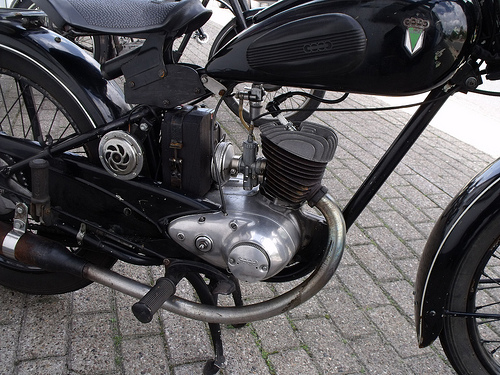<image>
Is the seat on the motorcycle? Yes. Looking at the image, I can see the seat is positioned on top of the motorcycle, with the motorcycle providing support. Is there a bike in front of the road? No. The bike is not in front of the road. The spatial positioning shows a different relationship between these objects. 